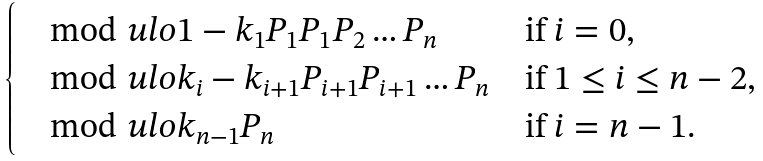Convert formula to latex. <formula><loc_0><loc_0><loc_500><loc_500>\begin{cases} \mod u l o { 1 - k _ { 1 } P _ { 1 } } { P _ { 1 } P _ { 2 } \dots P _ { n } } & \text {if $i=0$,} \\ \mod u l o { k _ { i } - k _ { i + 1 } P _ { i + 1 } } { P _ { i + 1 } \dots P _ { n } } & \text {if $1\leq i\leq n-2$,} \\ \mod u l o { k _ { n - 1 } } { P _ { n } } & \text {if $i=n-1$.} \end{cases}</formula> 